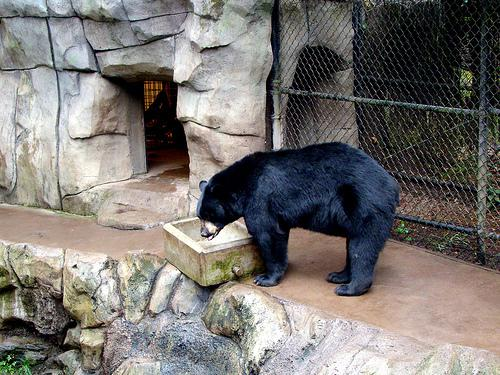Question: when was picture taken?
Choices:
A. During the night.
B. During the day.
C. In the summer.
D. In the winter.
Answer with the letter. Answer: B Question: who is probably taking the picture?
Choices:
A. A relative.
B. A child.
C. Visitor.
D. An employee.
Answer with the letter. Answer: C Question: what is the bear doing?
Choices:
A. Eating.
B. Drinking.
C. Napping.
D. Fishing.
Answer with the letter. Answer: B 